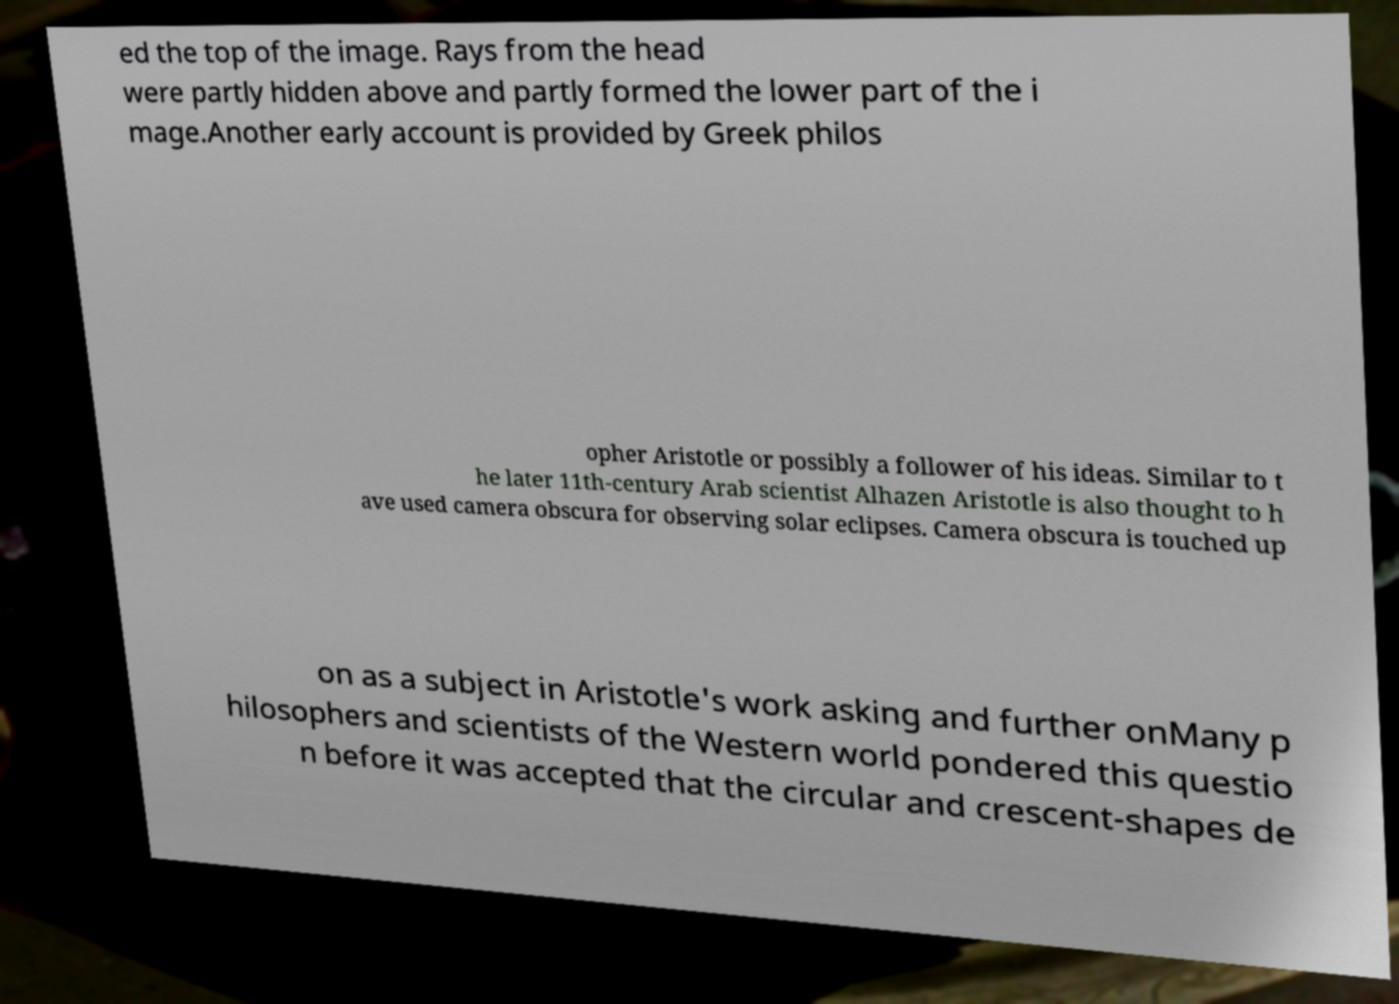Please read and relay the text visible in this image. What does it say? ed the top of the image. Rays from the head were partly hidden above and partly formed the lower part of the i mage.Another early account is provided by Greek philos opher Aristotle or possibly a follower of his ideas. Similar to t he later 11th-century Arab scientist Alhazen Aristotle is also thought to h ave used camera obscura for observing solar eclipses. Camera obscura is touched up on as a subject in Aristotle's work asking and further onMany p hilosophers and scientists of the Western world pondered this questio n before it was accepted that the circular and crescent-shapes de 